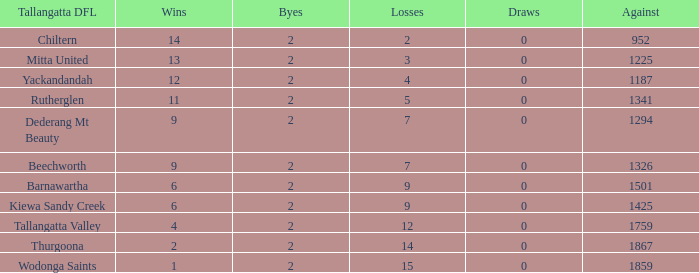What are the losses when there are 9 wins and more than 1326 against? None. 